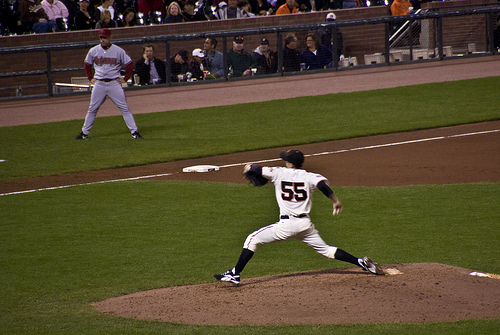Can you write a short story based on this image? Under the bright stadium lights, Jake, the seasoned pitcher, took a deep breath. The crowd's roar became a distant hum as he focused on the batter. In that moment, every practice session, every late night spent perfecting his curveball, culminated into this pitch. With his team relying on him, he wound up and let the ball fly, hoping it would lead them to victory. 